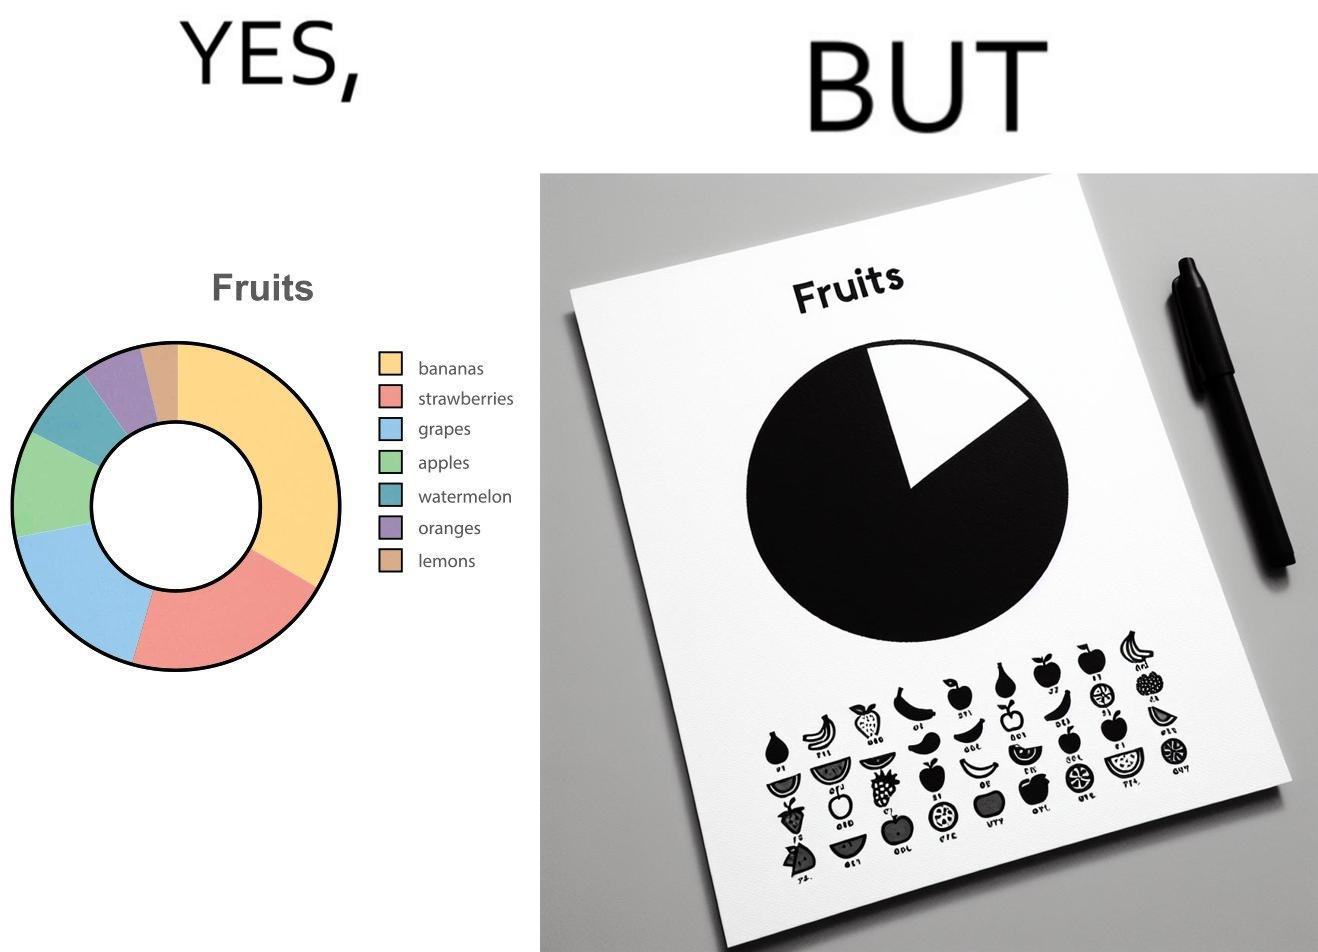Describe the content of this image. This is funny because the pie chart printout is useless as you cant see any divisions on it because the  printer could not capture the different colors 